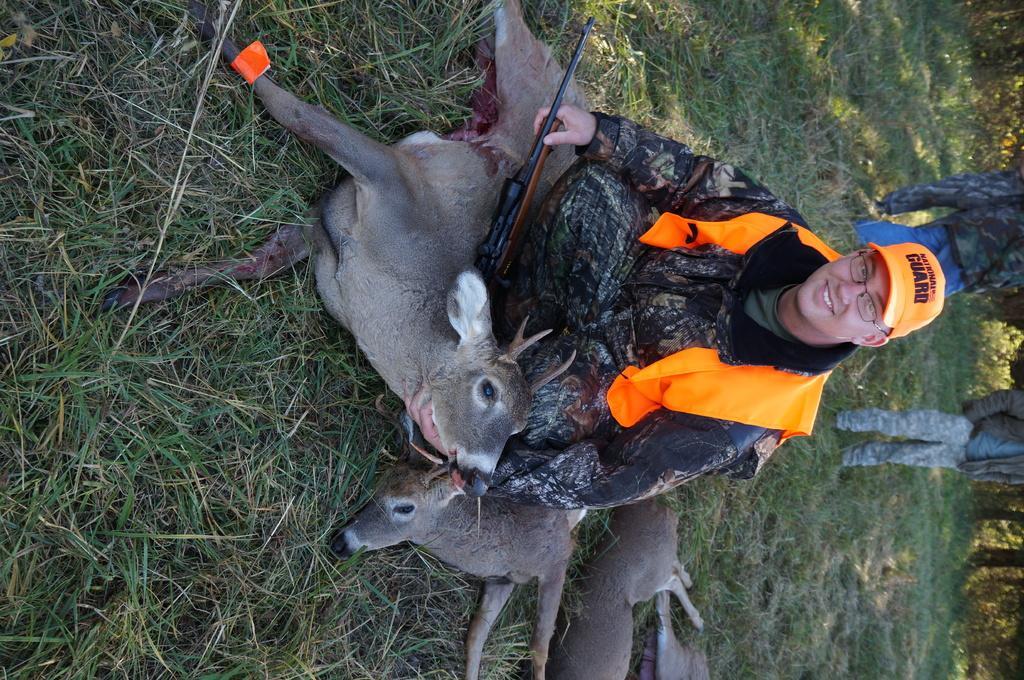Could you give a brief overview of what you see in this image? In the center of the image there is a person sitting with deers on the grass. In the background we can see grass, trees and persons. 